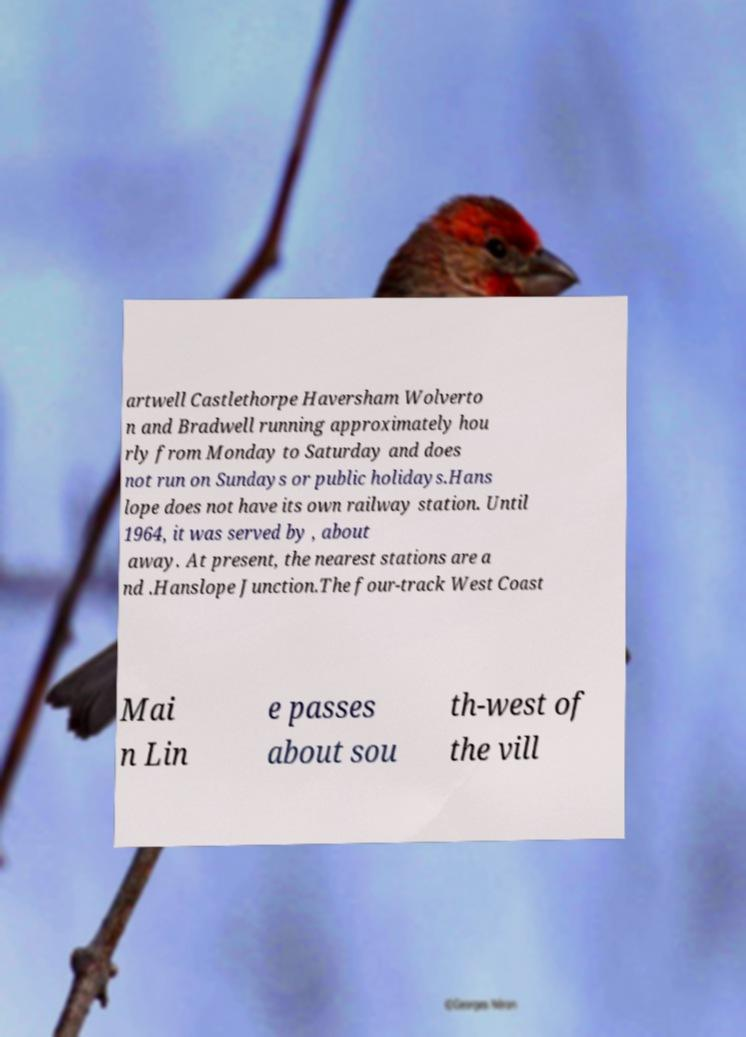What messages or text are displayed in this image? I need them in a readable, typed format. artwell Castlethorpe Haversham Wolverto n and Bradwell running approximately hou rly from Monday to Saturday and does not run on Sundays or public holidays.Hans lope does not have its own railway station. Until 1964, it was served by , about away. At present, the nearest stations are a nd .Hanslope Junction.The four-track West Coast Mai n Lin e passes about sou th-west of the vill 